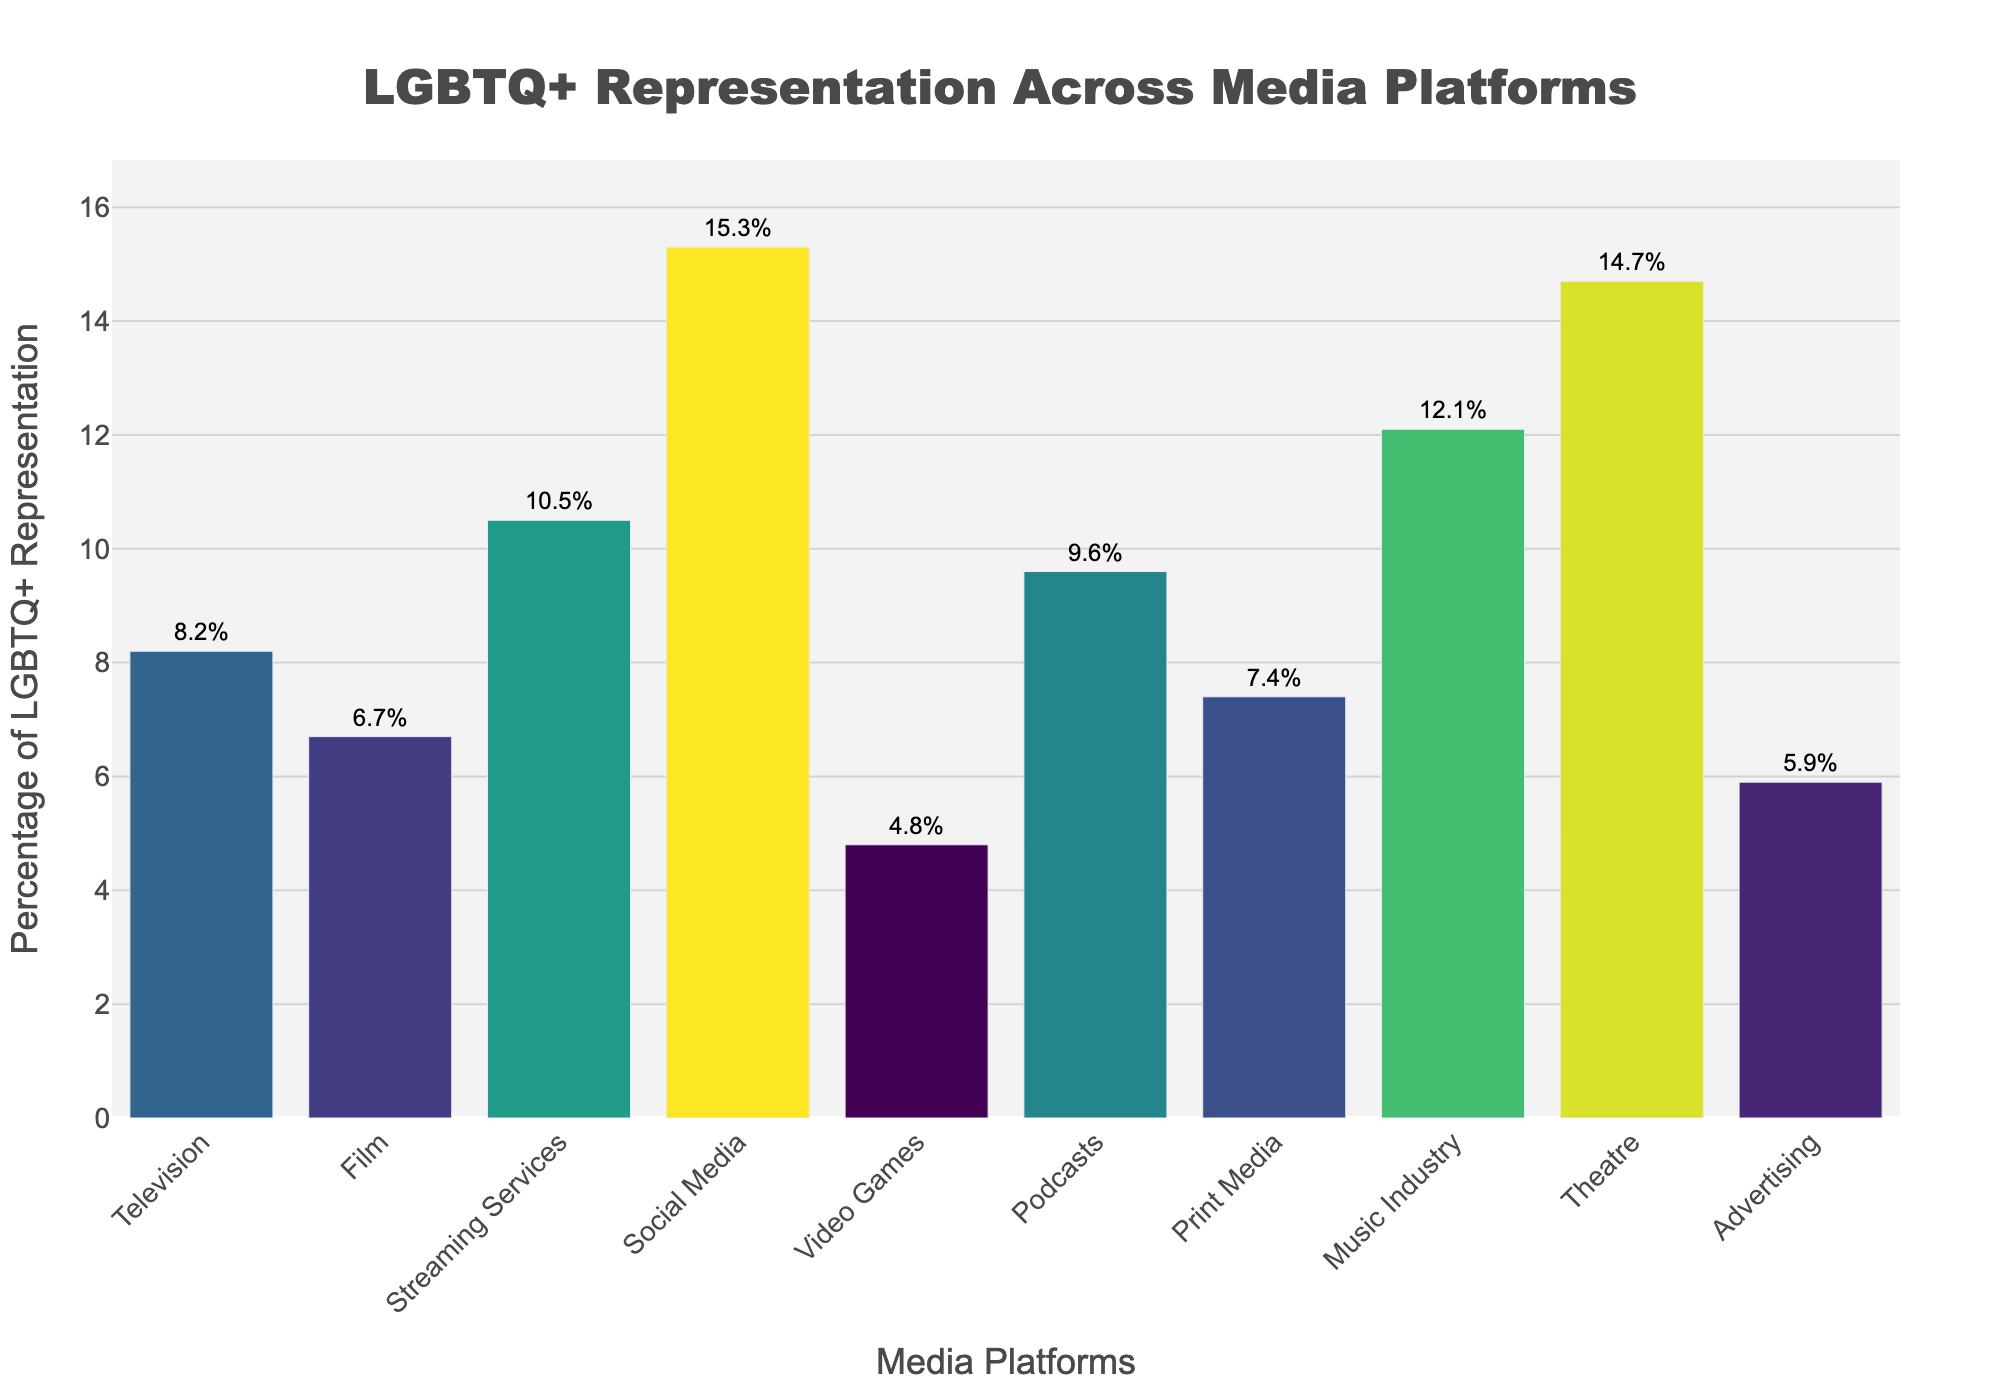Which media platform has the highest percentage of LGBTQ+ representation? The figure shows that Social Media has the tallest bar, indicating that it has the highest percentage.
Answer: Social Media Which media platform has the lowest percentage of LGBTQ+ representation? The figure shows that Video Games has the shortest bar, indicating that it has the lowest percentage.
Answer: Video Games How much higher is the LGBTQ+ representation percentage in Social Media compared to Film? The percentage for Social Media is 15.3% and for Film is 6.7%. Subtracting these values: 15.3 - 6.7 = 8.6%.
Answer: 8.6% Which media platforms have an LGBTQ+ representation percentage higher than 10%? The bars for Social Media, Streaming Services, Music Industry, and Theatre all extend beyond the 10% mark.
Answer: Social Media, Streaming Services, Music Industry, Theatre What is the average percentage of LGBTQ+ representation across all platforms? Sum the percentages: 8.2 + 6.7 + 10.5 + 15.3 + 4.8 + 9.6 + 7.4 + 12.1 + 14.7 + 5.9 = 95.2. There are 10 platforms. Average = 95.2 / 10 = 9.52%.
Answer: 9.52% How does the representation in Podcasts compare to Print Media? The bar for Podcasts is higher than the bar for Print Media. Podcasts have 9.6% and Print Media has 7.4%.
Answer: Podcasts have a higher representation Which media platform has a nearly 10% representation of LGBTQ+? The bar for Podcasts is closest to 10%, showing a percentage of 9.6%.
Answer: Podcasts What is the difference in LGBTQ+ representation between the Music Industry and Advertising? The Music Industry has 12.1% and Advertising has 5.9%. The difference is 12.1 - 5.9 = 6.2%.
Answer: 6.2% Rank the platforms from highest to lowest in terms of LGBTQ+ representation. The order is determined by the bar heights: Social Media > Theatre > Music Industry > Streaming Services > Podcasts > Television > Print Media > Advertising > Film > Video Games.
Answer: Social Media, Theatre, Music Industry, Streaming Services, Podcasts, Television, Print Media, Advertising, Film, Video Games What's the combined percentage of LGBTQ+ representation for Television and Theatre? Television is 8.2% and Theatre is 14.7%. The combined percentage is 8.2 + 14.7 = 22.9%.
Answer: 22.9% 